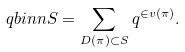<formula> <loc_0><loc_0><loc_500><loc_500>\ q b i n n S = \sum _ { D ( \pi ) \subset S } q ^ { \in v ( \pi ) } .</formula> 